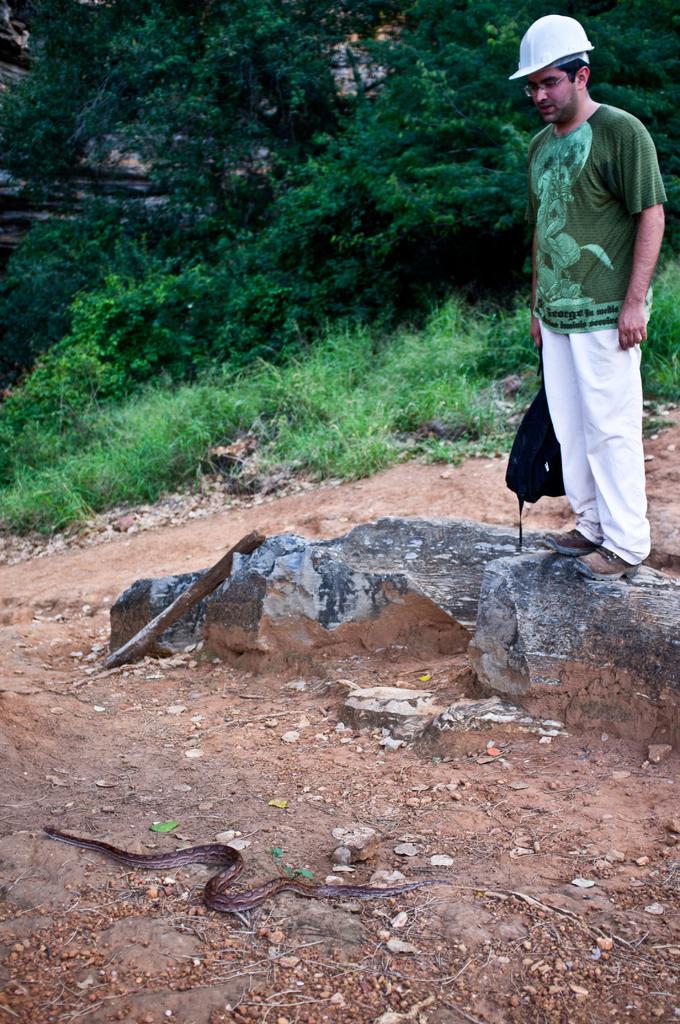Could you give a brief overview of what you see in this image? In this image, we can see a person is standing on the rock and holding a bag, wearing a helmet and glasses. At the bottom, a snake is moving on the ground. Background there are so many trees, glass, plants we can see. 